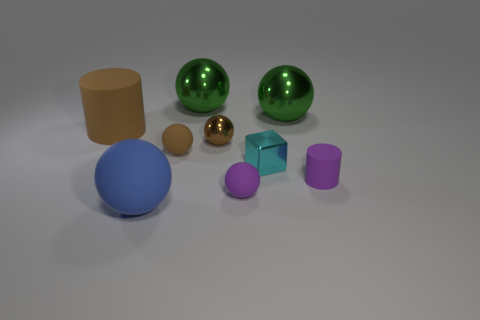Subtract all large rubber balls. How many balls are left? 5 Subtract all brown spheres. How many spheres are left? 4 Subtract all gray spheres. Subtract all purple cylinders. How many spheres are left? 6 Subtract all balls. How many objects are left? 3 Subtract all brown shiny spheres. Subtract all purple objects. How many objects are left? 6 Add 4 small brown balls. How many small brown balls are left? 6 Add 9 large blue things. How many large blue things exist? 10 Subtract 0 blue cylinders. How many objects are left? 9 